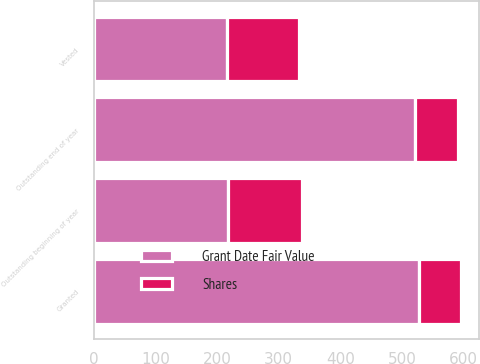Convert chart. <chart><loc_0><loc_0><loc_500><loc_500><stacked_bar_chart><ecel><fcel>Outstanding beginning of year<fcel>Granted<fcel>Vested<fcel>Outstanding end of year<nl><fcel>Shares<fcel>120<fcel>68<fcel>117<fcel>71<nl><fcel>Grant Date Fair Value<fcel>218.34<fcel>527.45<fcel>215.76<fcel>520.27<nl></chart> 